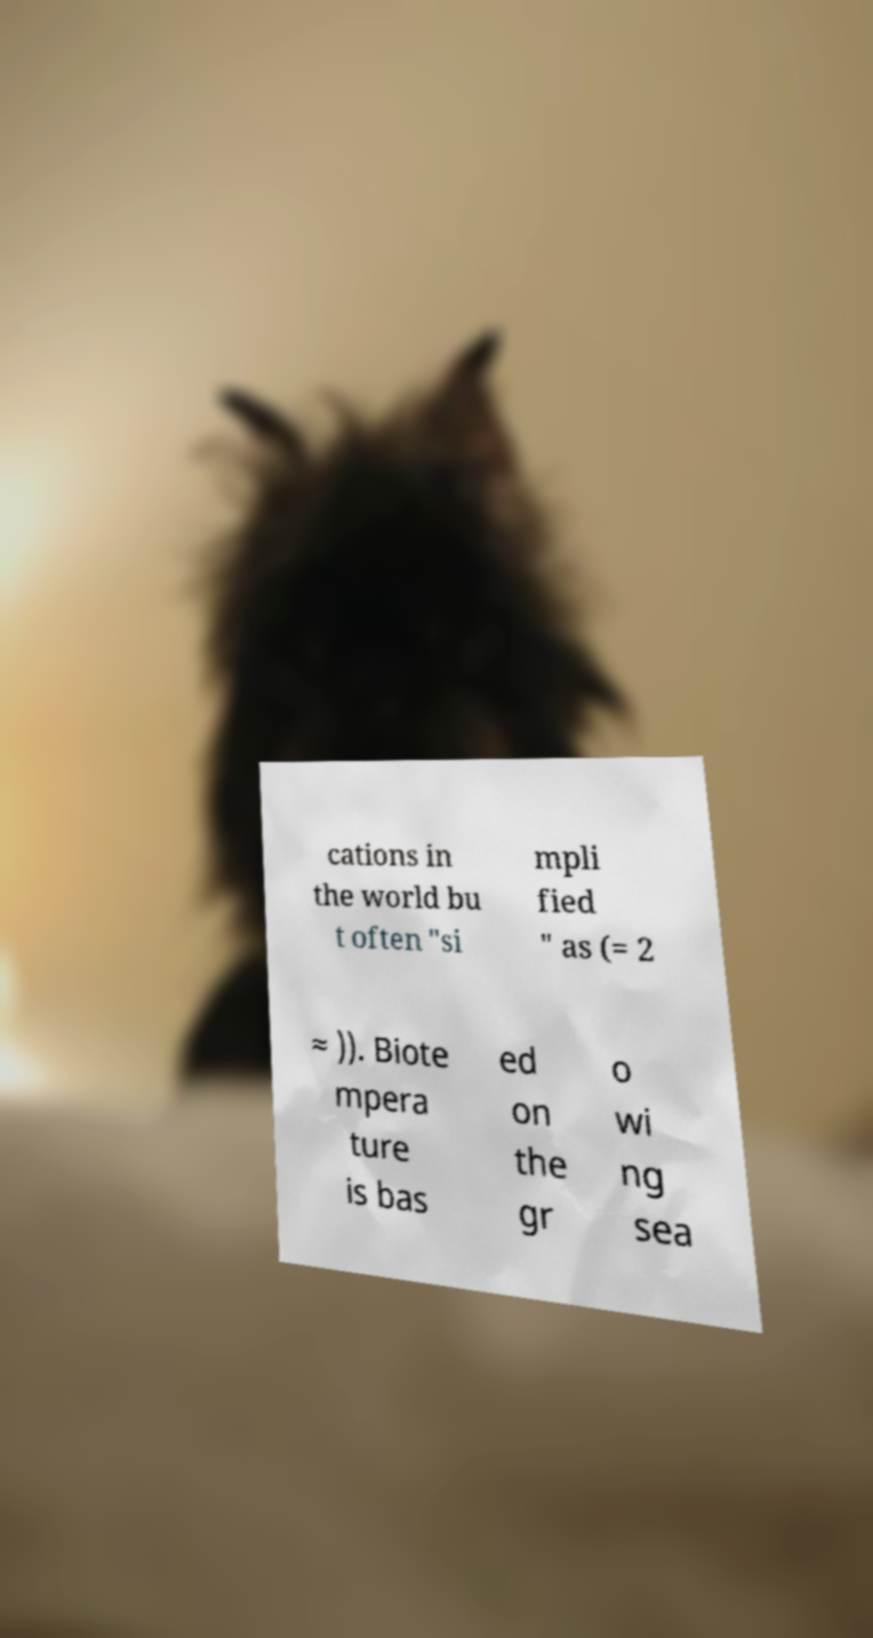Could you assist in decoding the text presented in this image and type it out clearly? cations in the world bu t often "si mpli fied " as (= 2 ≈ )). Biote mpera ture is bas ed on the gr o wi ng sea 